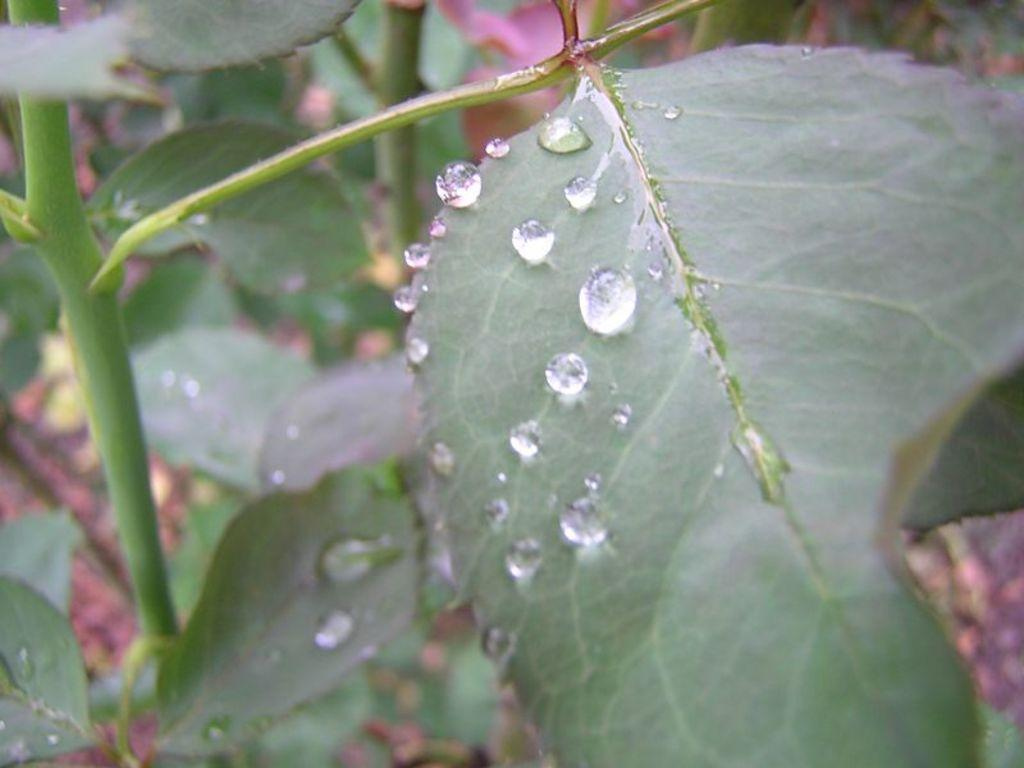What is the main subject of the image? The main subject of the image is a branch with leaves. Are there any additional features on the leaves? Yes, there are water drops on the leaves in the image. What type of card is being used to wipe the wax off the leaves in the image? There is no card or wax present in the image; it only features a branch with leaves and water drops. 